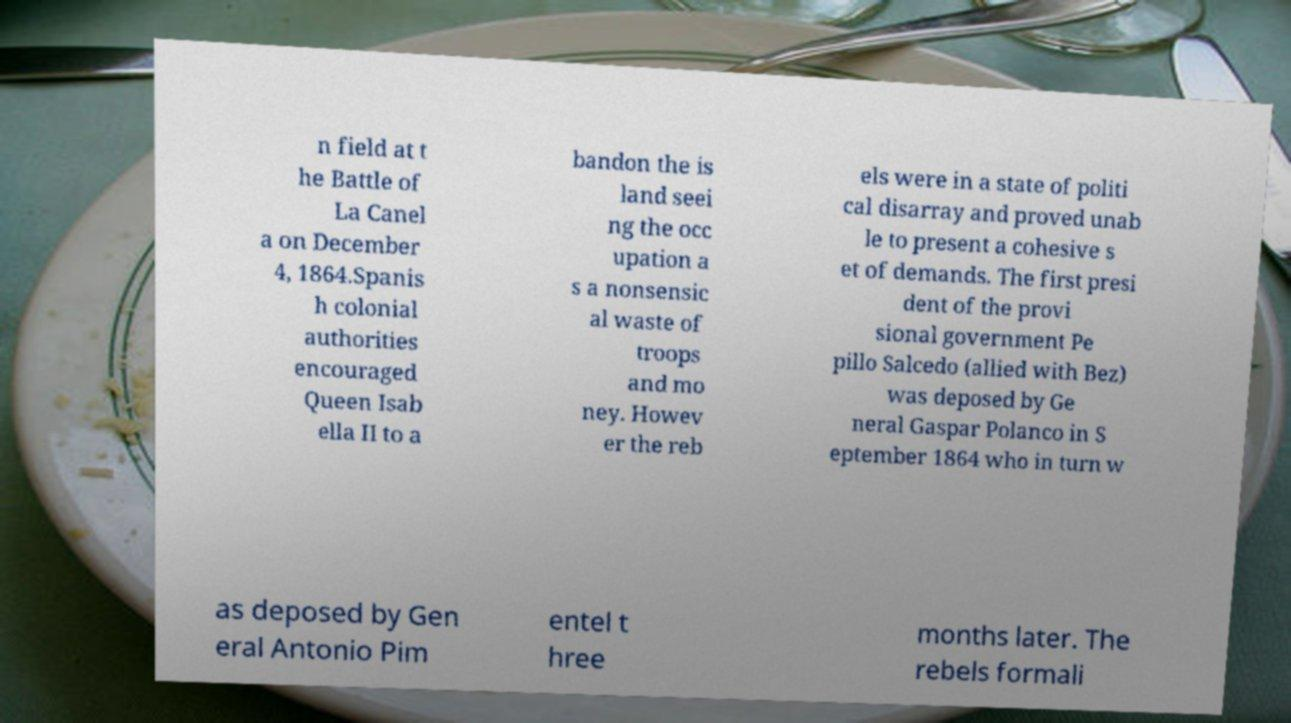Can you accurately transcribe the text from the provided image for me? n field at t he Battle of La Canel a on December 4, 1864.Spanis h colonial authorities encouraged Queen Isab ella II to a bandon the is land seei ng the occ upation a s a nonsensic al waste of troops and mo ney. Howev er the reb els were in a state of politi cal disarray and proved unab le to present a cohesive s et of demands. The first presi dent of the provi sional government Pe pillo Salcedo (allied with Bez) was deposed by Ge neral Gaspar Polanco in S eptember 1864 who in turn w as deposed by Gen eral Antonio Pim entel t hree months later. The rebels formali 